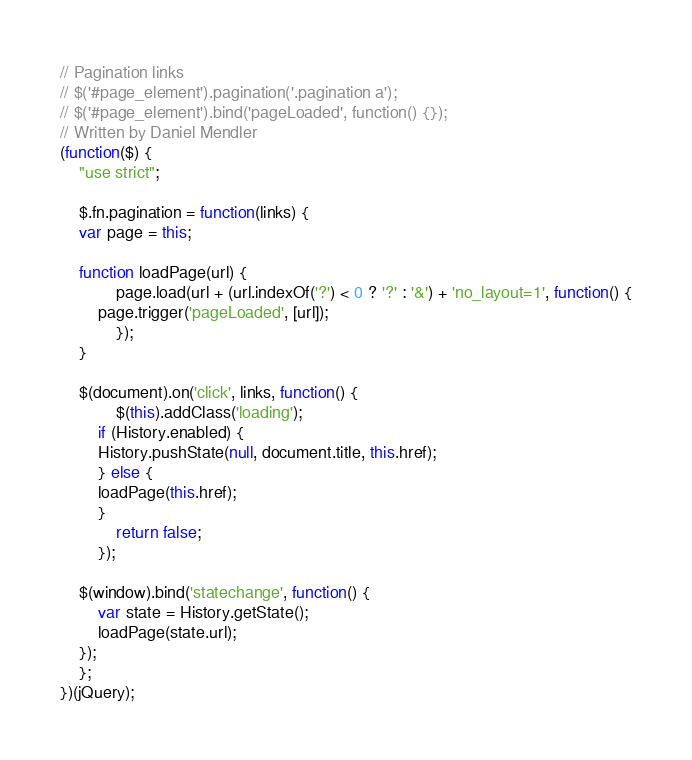Convert code to text. <code><loc_0><loc_0><loc_500><loc_500><_JavaScript_>// Pagination links
// $('#page_element').pagination('.pagination a');
// $('#page_element').bind('pageLoaded', function() {});
// Written by Daniel Mendler
(function($) {
    "use strict";

    $.fn.pagination = function(links) {
	var page = this;

	function loadPage(url) {
            page.load(url + (url.indexOf('?') < 0 ? '?' : '&') + 'no_layout=1', function() {
		page.trigger('pageLoaded', [url]);
            });
	}

	$(document).on('click', links, function() {
            $(this).addClass('loading');
	    if (History.enabled) {
		History.pushState(null, document.title, this.href);
	    } else {
		loadPage(this.href);
	    }
            return false;
        });

	$(window).bind('statechange', function() {
	    var state = History.getState();
	    loadPage(state.url);
	});
    };
})(jQuery);
</code> 